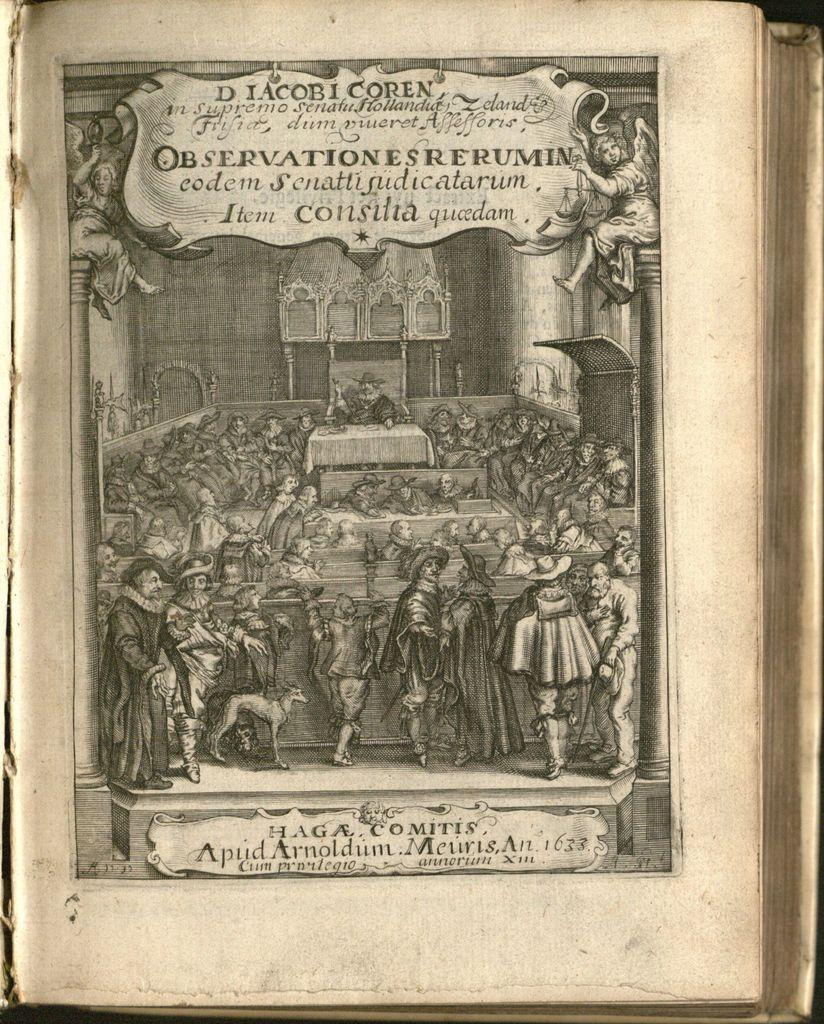What is present in the image? There is a book in the image. What can be seen on the front page of the book? Something is written on the front page of the book. What else is inside the book? There is an image in the book. What is depicted in the image? The image contains many people. What type of ball is being used by the queen in the image? There is no queen or ball present in the image; it contains an image of many people. 